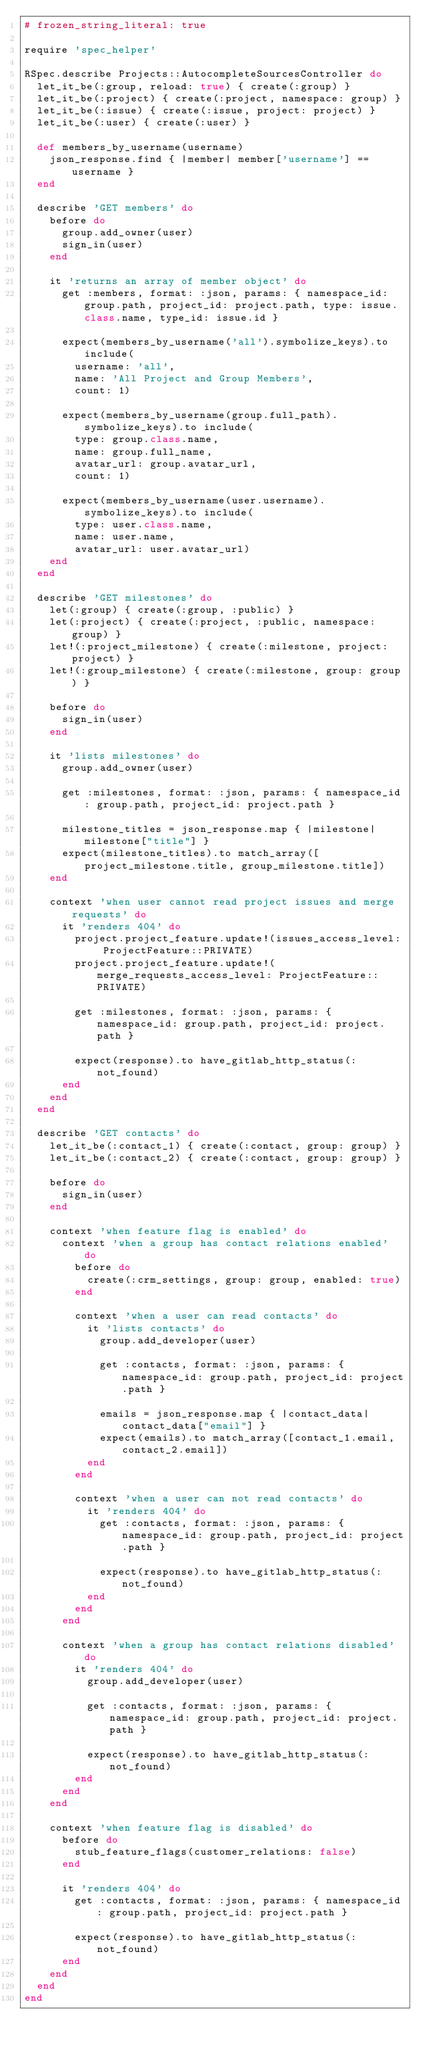Convert code to text. <code><loc_0><loc_0><loc_500><loc_500><_Ruby_># frozen_string_literal: true

require 'spec_helper'

RSpec.describe Projects::AutocompleteSourcesController do
  let_it_be(:group, reload: true) { create(:group) }
  let_it_be(:project) { create(:project, namespace: group) }
  let_it_be(:issue) { create(:issue, project: project) }
  let_it_be(:user) { create(:user) }

  def members_by_username(username)
    json_response.find { |member| member['username'] == username }
  end

  describe 'GET members' do
    before do
      group.add_owner(user)
      sign_in(user)
    end

    it 'returns an array of member object' do
      get :members, format: :json, params: { namespace_id: group.path, project_id: project.path, type: issue.class.name, type_id: issue.id }

      expect(members_by_username('all').symbolize_keys).to include(
        username: 'all',
        name: 'All Project and Group Members',
        count: 1)

      expect(members_by_username(group.full_path).symbolize_keys).to include(
        type: group.class.name,
        name: group.full_name,
        avatar_url: group.avatar_url,
        count: 1)

      expect(members_by_username(user.username).symbolize_keys).to include(
        type: user.class.name,
        name: user.name,
        avatar_url: user.avatar_url)
    end
  end

  describe 'GET milestones' do
    let(:group) { create(:group, :public) }
    let(:project) { create(:project, :public, namespace: group) }
    let!(:project_milestone) { create(:milestone, project: project) }
    let!(:group_milestone) { create(:milestone, group: group) }

    before do
      sign_in(user)
    end

    it 'lists milestones' do
      group.add_owner(user)

      get :milestones, format: :json, params: { namespace_id: group.path, project_id: project.path }

      milestone_titles = json_response.map { |milestone| milestone["title"] }
      expect(milestone_titles).to match_array([project_milestone.title, group_milestone.title])
    end

    context 'when user cannot read project issues and merge requests' do
      it 'renders 404' do
        project.project_feature.update!(issues_access_level: ProjectFeature::PRIVATE)
        project.project_feature.update!(merge_requests_access_level: ProjectFeature::PRIVATE)

        get :milestones, format: :json, params: { namespace_id: group.path, project_id: project.path }

        expect(response).to have_gitlab_http_status(:not_found)
      end
    end
  end

  describe 'GET contacts' do
    let_it_be(:contact_1) { create(:contact, group: group) }
    let_it_be(:contact_2) { create(:contact, group: group) }

    before do
      sign_in(user)
    end

    context 'when feature flag is enabled' do
      context 'when a group has contact relations enabled' do
        before do
          create(:crm_settings, group: group, enabled: true)
        end

        context 'when a user can read contacts' do
          it 'lists contacts' do
            group.add_developer(user)

            get :contacts, format: :json, params: { namespace_id: group.path, project_id: project.path }

            emails = json_response.map { |contact_data| contact_data["email"] }
            expect(emails).to match_array([contact_1.email, contact_2.email])
          end
        end

        context 'when a user can not read contacts' do
          it 'renders 404' do
            get :contacts, format: :json, params: { namespace_id: group.path, project_id: project.path }

            expect(response).to have_gitlab_http_status(:not_found)
          end
        end
      end

      context 'when a group has contact relations disabled' do
        it 'renders 404' do
          group.add_developer(user)

          get :contacts, format: :json, params: { namespace_id: group.path, project_id: project.path }

          expect(response).to have_gitlab_http_status(:not_found)
        end
      end
    end

    context 'when feature flag is disabled' do
      before do
        stub_feature_flags(customer_relations: false)
      end

      it 'renders 404' do
        get :contacts, format: :json, params: { namespace_id: group.path, project_id: project.path }

        expect(response).to have_gitlab_http_status(:not_found)
      end
    end
  end
end
</code> 